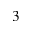Convert formula to latex. <formula><loc_0><loc_0><loc_500><loc_500>_ { 3 }</formula> 